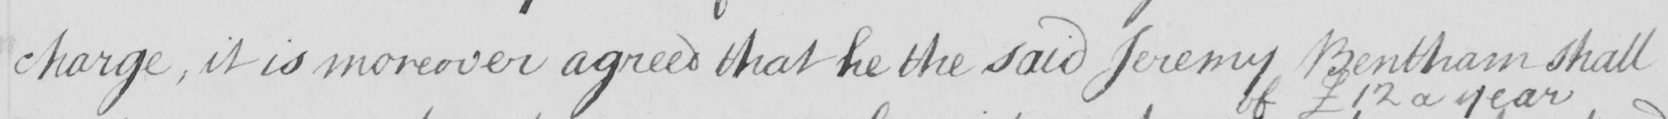What is written in this line of handwriting? charge , it is moreover agreed that he the said Jeremy Bentham shall 